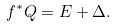<formula> <loc_0><loc_0><loc_500><loc_500>f ^ { * } Q = E + \Delta .</formula> 